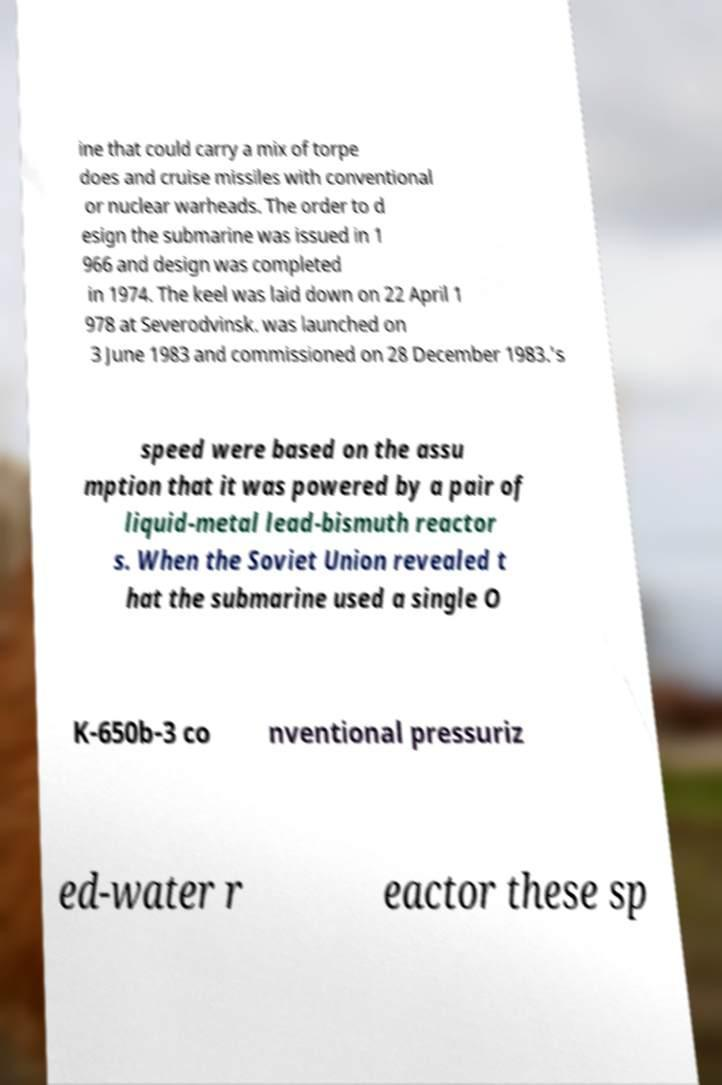Please identify and transcribe the text found in this image. ine that could carry a mix of torpe does and cruise missiles with conventional or nuclear warheads. The order to d esign the submarine was issued in 1 966 and design was completed in 1974. The keel was laid down on 22 April 1 978 at Severodvinsk. was launched on 3 June 1983 and commissioned on 28 December 1983.'s speed were based on the assu mption that it was powered by a pair of liquid-metal lead-bismuth reactor s. When the Soviet Union revealed t hat the submarine used a single O K-650b-3 co nventional pressuriz ed-water r eactor these sp 